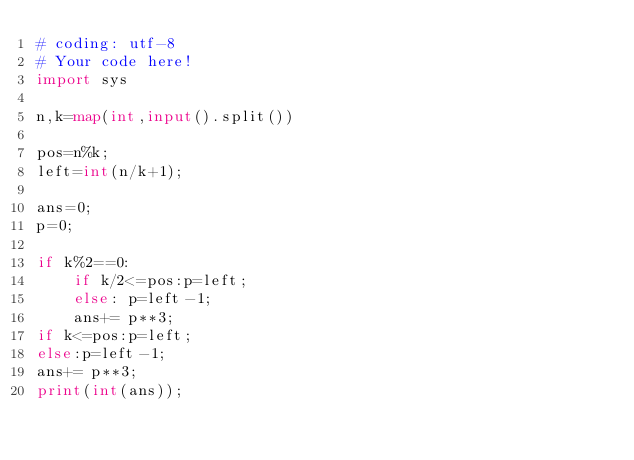<code> <loc_0><loc_0><loc_500><loc_500><_Python_># coding: utf-8
# Your code here!
import sys

n,k=map(int,input().split())

pos=n%k;
left=int(n/k+1);

ans=0;
p=0;

if k%2==0:
    if k/2<=pos:p=left;
    else: p=left-1;
    ans+= p**3;
if k<=pos:p=left;
else:p=left-1;
ans+= p**3;
print(int(ans));
</code> 